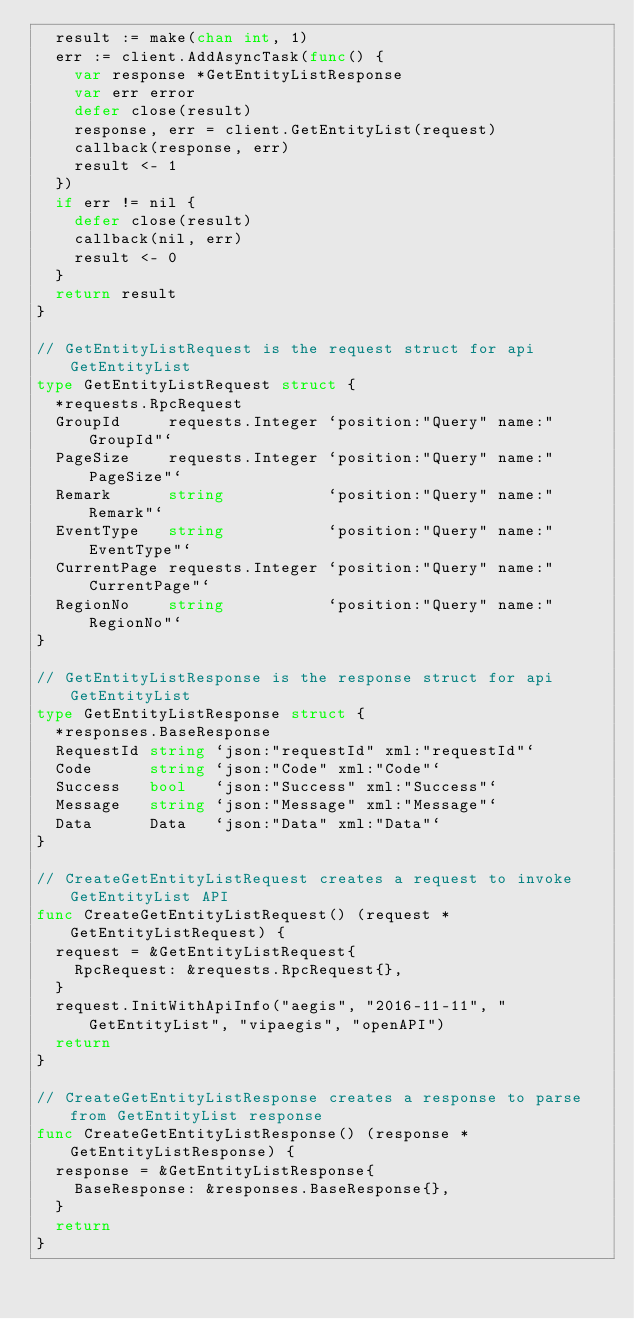Convert code to text. <code><loc_0><loc_0><loc_500><loc_500><_Go_>	result := make(chan int, 1)
	err := client.AddAsyncTask(func() {
		var response *GetEntityListResponse
		var err error
		defer close(result)
		response, err = client.GetEntityList(request)
		callback(response, err)
		result <- 1
	})
	if err != nil {
		defer close(result)
		callback(nil, err)
		result <- 0
	}
	return result
}

// GetEntityListRequest is the request struct for api GetEntityList
type GetEntityListRequest struct {
	*requests.RpcRequest
	GroupId     requests.Integer `position:"Query" name:"GroupId"`
	PageSize    requests.Integer `position:"Query" name:"PageSize"`
	Remark      string           `position:"Query" name:"Remark"`
	EventType   string           `position:"Query" name:"EventType"`
	CurrentPage requests.Integer `position:"Query" name:"CurrentPage"`
	RegionNo    string           `position:"Query" name:"RegionNo"`
}

// GetEntityListResponse is the response struct for api GetEntityList
type GetEntityListResponse struct {
	*responses.BaseResponse
	RequestId string `json:"requestId" xml:"requestId"`
	Code      string `json:"Code" xml:"Code"`
	Success   bool   `json:"Success" xml:"Success"`
	Message   string `json:"Message" xml:"Message"`
	Data      Data   `json:"Data" xml:"Data"`
}

// CreateGetEntityListRequest creates a request to invoke GetEntityList API
func CreateGetEntityListRequest() (request *GetEntityListRequest) {
	request = &GetEntityListRequest{
		RpcRequest: &requests.RpcRequest{},
	}
	request.InitWithApiInfo("aegis", "2016-11-11", "GetEntityList", "vipaegis", "openAPI")
	return
}

// CreateGetEntityListResponse creates a response to parse from GetEntityList response
func CreateGetEntityListResponse() (response *GetEntityListResponse) {
	response = &GetEntityListResponse{
		BaseResponse: &responses.BaseResponse{},
	}
	return
}
</code> 